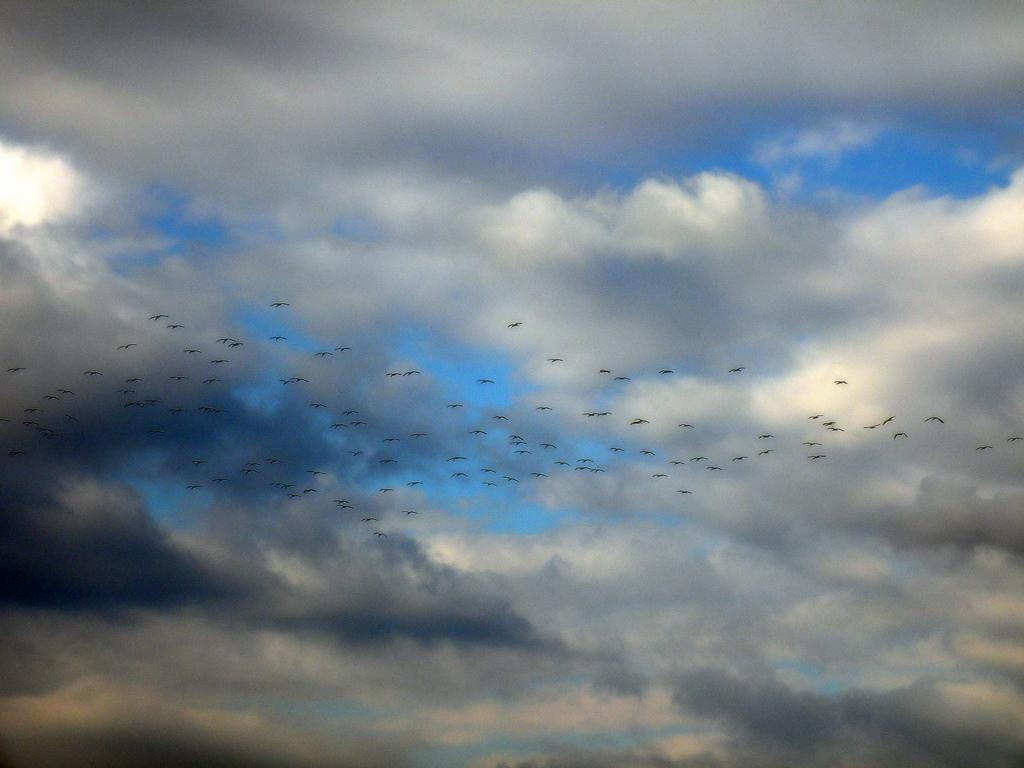What is happening in the sky in the image? There are birds flying in the air. What is the condition of the sky in the image? The sky is cloudy. What type of jelly can be seen on the cart in the image? There is no cart or jelly present in the image; it features birds flying in a cloudy sky. How many snails are crawling on the birds in the image? There are no snails present in the image; it features birds flying in a cloudy sky. 